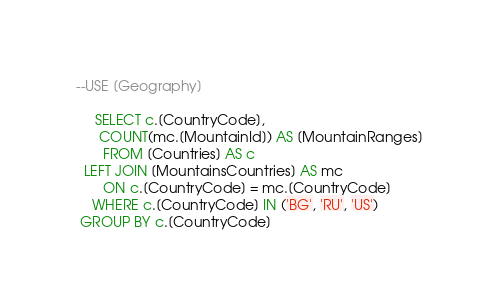Convert code to text. <code><loc_0><loc_0><loc_500><loc_500><_SQL_>--USE [Geography]

     SELECT c.[CountryCode],
      COUNT(mc.[MountainId]) AS [MountainRanges]
       FROM [Countries] AS c
  LEFT JOIN [MountainsCountries] AS mc
       ON c.[CountryCode] = mc.[CountryCode]
    WHERE c.[CountryCode] IN ('BG', 'RU', 'US')
 GROUP BY c.[CountryCode]</code> 